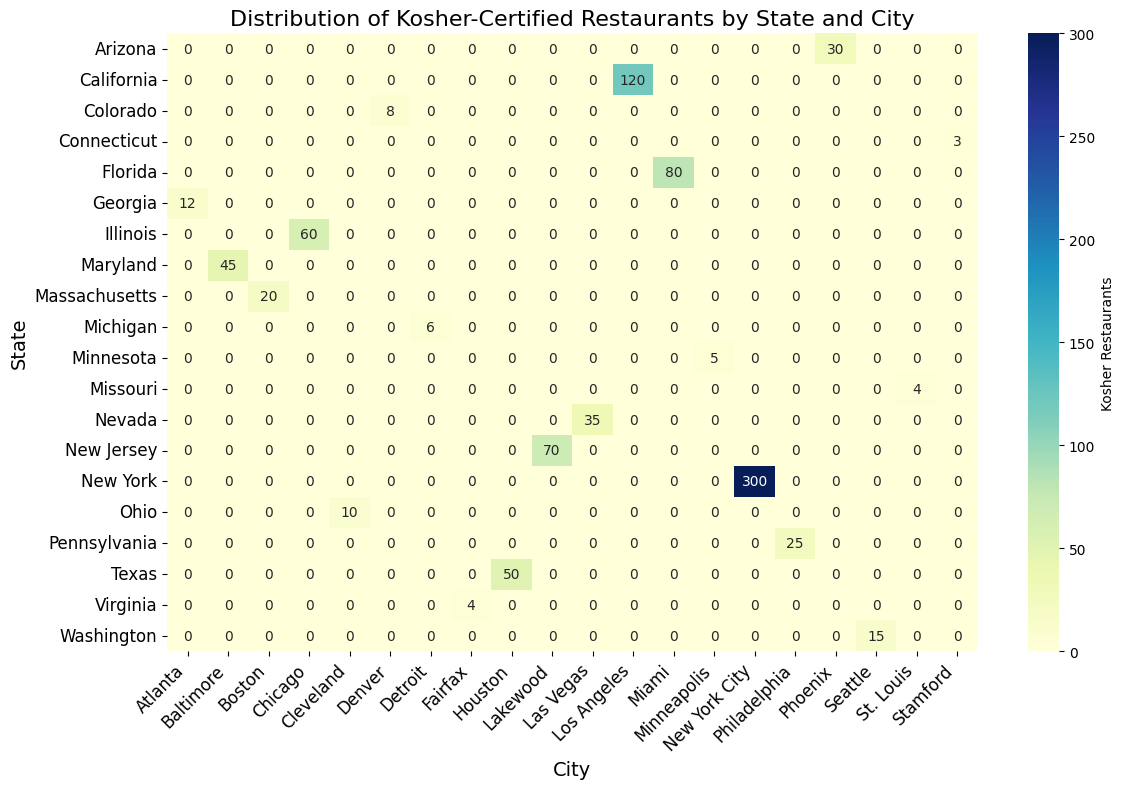Which city has the highest number of kosher-certified restaurants? The city with the highest number will have the darkest color in the heatmap and the highest numeric value among all the labels. By observing, New York City, NY, has the darkest color and the value 300.
Answer: New York City Which city in California has the most kosher-certified restaurants? To find the city in California with the most kosher-certified restaurants, locate the 'California' row and check the labelled values. Los Angeles has a value of 120, the highest in California.
Answer: Los Angeles Comparing Miami, FL, and Lakewood, NJ, which city has more kosher-certified restaurants? Look at the values for Miami in Florida and Lakewood in New Jersey. Miami has 80 and Lakewood has 70. 80 is greater than 70.
Answer: Miami Among New York, Illinois, and Texas, which state has the least total number of kosher-certified grocery stores and restaurants together? Sum up the values of kosher-certified restaurants and grocery stores for each state: NY (345), IL (68), TX (57). Texas has the lowest sum.Total (Restaurants + Grocery Stores) for Texas = 50 + 7 = 57, New York = 300 + 45 = 345, Illinois = Kosher Restaurants (60) + Kosher Grocery Stores (8) = 68
Answer: Texas What is the difference between the number of kosher-certified restaurants in Chicago, IL, and Phoenix, AZ? Look at the values for Chicago and Phoenix. Chicago has 60 restaurants, and Phoenix has 30 restaurants. The difference is 60 - 30.
Answer: 30 Which state has a city with only 3 kosher-certified restaurants and 1 grocery store? Look for the row and column intersection in the heatmap that shows 3. Identify the state and city. Stamford, Connecticut is the city with 3 kosher-certified restaurants and 1 grocery store.
Answer: Connecticut Which has more kosher-certified grocery stores: Maryland or Massachusetts? Identify the values in the intersection for Maryland and Massachusetts. Maryland has 6, and Massachusetts has 3.
Answer: Maryland Are there any cities with more kosher grocery stores than kosher restaurants? Check each row and column to see if any city shows a higher number in kosher grocery stores than in kosher restaurants. According to the data and visual, all cities have more kosher restaurants than grocery stores.
Answer: No What is the combined total number of kosher-certified restaurants and grocery stores in Houston, TX? Add up the kosher-certified restaurants and grocery stores values for Houston. 50 (restaurants) + 7 (grocery stores) = 57.
Answer: 57 